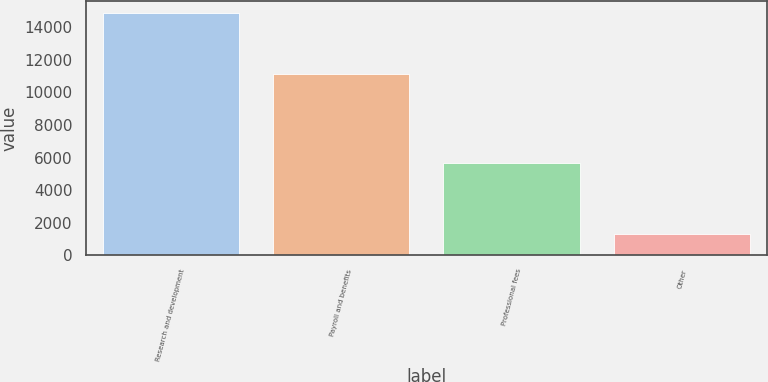Convert chart to OTSL. <chart><loc_0><loc_0><loc_500><loc_500><bar_chart><fcel>Research and development<fcel>Payroll and benefits<fcel>Professional fees<fcel>Other<nl><fcel>14883<fcel>11114<fcel>5658<fcel>1296<nl></chart> 